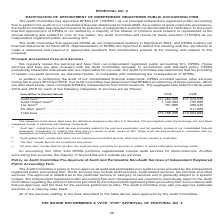According to Nortonlifelock's financial document, What is the public accounting firm that the company engages? According to the financial document, KPMG. The relevant text states: "The Audit Committee has appointed KPMG LLP (‘‘KPMG’’) as our principal independent registered public accounting firm to perform the audit The Audit Committee has appointed KPMG LLP (‘‘KPMG’’) as our p..." Also, What fiscal years are in the table? The document shows two values: FY19 and FY18. From the document: "Fees Billed to NortonLifeLock FY19 FY18 Fees Billed to NortonLifeLock FY19 FY18..." Also, What does Tax fees include? fees for tax compliance and advice. The document states: "(3) ‘‘Tax fees’’ include fees for tax compliance and advice...." Also, can you calculate: What is the average total fees for FY18 and FY19? To answer this question, I need to perform calculations using the financial data. The calculation is: (13,768,398+12,904,663)/2, which equals 13336530.5. This is based on the information: "Total fees . $13,768,398 $12,904,663 Total fees . $13,768,398 $12,904,663..." The key data points involved are: 12,904,663, 13,768,398. Also, can you calculate: What is the difference in total fees for FY19 comapred to FY18? Based on the calculation: 13,768,398-12,904,663, the result is 863735. This is based on the information: "Total fees . $13,768,398 $12,904,663 Total fees . $13,768,398 $12,904,663..." The key data points involved are: 12,904,663, 13,768,398. Also, can you calculate: What is the percentage increase in Audit related fees from FY18 to FY19? To answer this question, I need to perform calculations using the financial data. The calculation is: (1,142,383-753,689)/753,689, which equals 51.57 (percentage). This is based on the information: "$12,464,329 $11,370,525 Audit related fees (2) . 1,142,383 753,689 Tax fees (3) . 161,685 469,449 All other fees (4) . 0 311,000 29 $11,370,525 Audit related fees (2) . 1,142,383 753,689 Tax fees (3) ..." The key data points involved are: 1,142,383, 753,689. 